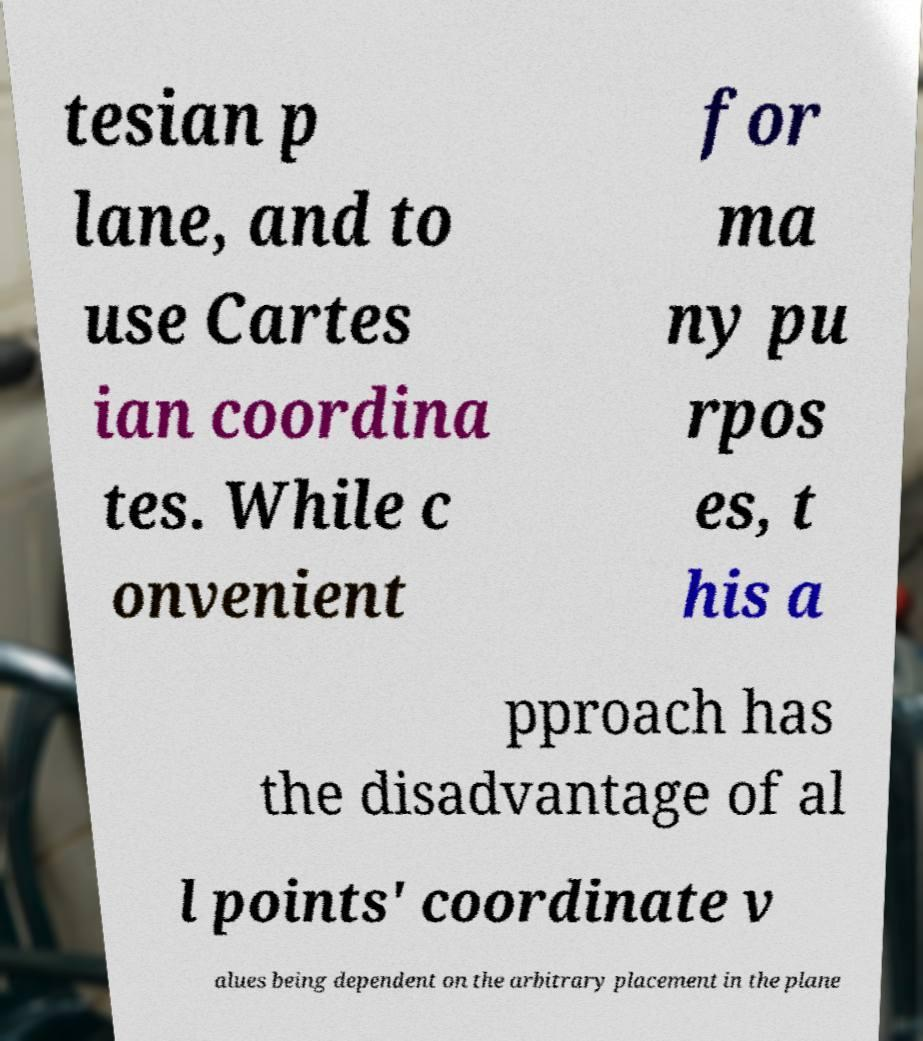Could you extract and type out the text from this image? tesian p lane, and to use Cartes ian coordina tes. While c onvenient for ma ny pu rpos es, t his a pproach has the disadvantage of al l points' coordinate v alues being dependent on the arbitrary placement in the plane 